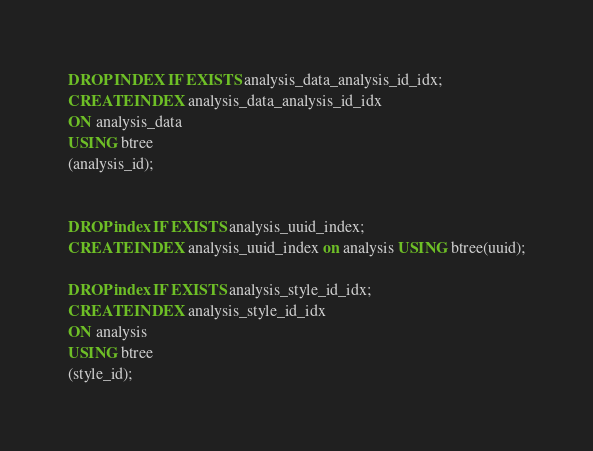Convert code to text. <code><loc_0><loc_0><loc_500><loc_500><_SQL_>DROP INDEX IF EXISTS analysis_data_analysis_id_idx;
CREATE INDEX analysis_data_analysis_id_idx
ON analysis_data
USING btree
(analysis_id);


DROP index IF EXISTS analysis_uuid_index;
CREATE INDEX analysis_uuid_index on analysis USING btree(uuid);

DROP index IF EXISTS analysis_style_id_idx;
CREATE INDEX analysis_style_id_idx
ON analysis
USING btree
(style_id);
</code> 